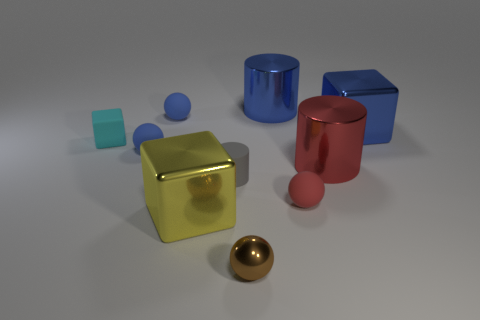Subtract all matte balls. How many balls are left? 1 Subtract all blue cylinders. How many cylinders are left? 2 Subtract all cylinders. How many objects are left? 7 Subtract 3 cylinders. How many cylinders are left? 0 Add 7 large red metal cubes. How many large red metal cubes exist? 7 Subtract 0 gray cubes. How many objects are left? 10 Subtract all gray spheres. Subtract all green blocks. How many spheres are left? 4 Subtract all brown cylinders. How many red spheres are left? 1 Subtract all shiny balls. Subtract all red balls. How many objects are left? 8 Add 2 tiny blue rubber balls. How many tiny blue rubber balls are left? 4 